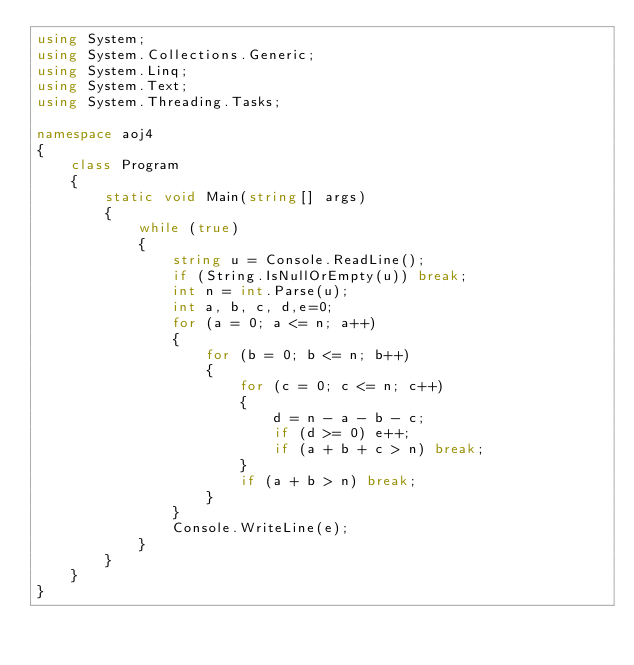Convert code to text. <code><loc_0><loc_0><loc_500><loc_500><_C#_>using System;
using System.Collections.Generic;
using System.Linq;
using System.Text;
using System.Threading.Tasks;

namespace aoj4
{
    class Program
    {
        static void Main(string[] args)
        {
            while (true)
            {
                string u = Console.ReadLine();
                if (String.IsNullOrEmpty(u)) break;
                int n = int.Parse(u);
                int a, b, c, d,e=0;
                for (a = 0; a <= n; a++)
                {
                    for (b = 0; b <= n; b++)
                    {
                        for (c = 0; c <= n; c++)
                        {
                            d = n - a - b - c;
                            if (d >= 0) e++;
                            if (a + b + c > n) break;
                        }
                        if (a + b > n) break;
                    }
                }
                Console.WriteLine(e);
            }
        }
    }
}</code> 